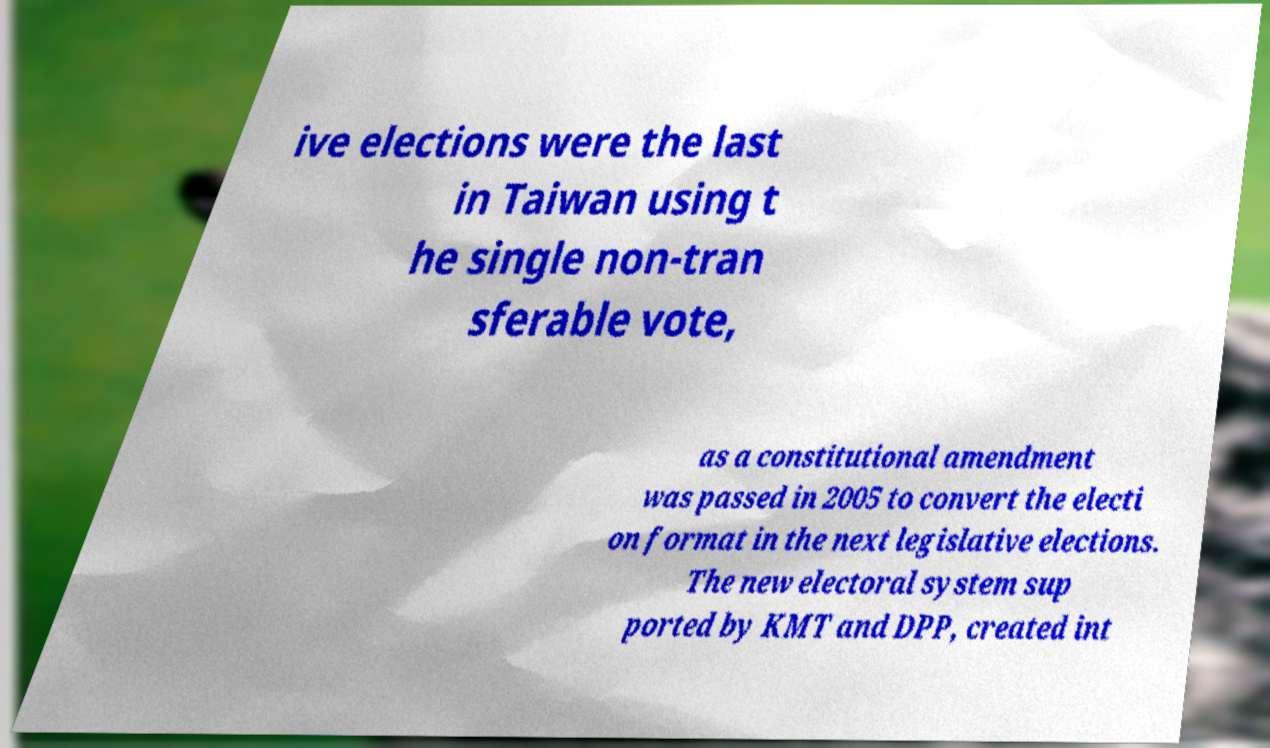Please read and relay the text visible in this image. What does it say? ive elections were the last in Taiwan using t he single non-tran sferable vote, as a constitutional amendment was passed in 2005 to convert the electi on format in the next legislative elections. The new electoral system sup ported by KMT and DPP, created int 